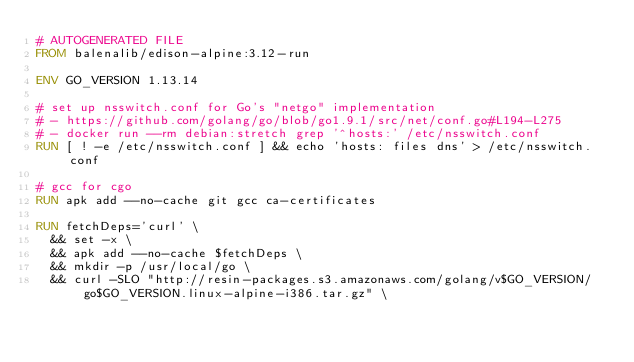Convert code to text. <code><loc_0><loc_0><loc_500><loc_500><_Dockerfile_># AUTOGENERATED FILE
FROM balenalib/edison-alpine:3.12-run

ENV GO_VERSION 1.13.14

# set up nsswitch.conf for Go's "netgo" implementation
# - https://github.com/golang/go/blob/go1.9.1/src/net/conf.go#L194-L275
# - docker run --rm debian:stretch grep '^hosts:' /etc/nsswitch.conf
RUN [ ! -e /etc/nsswitch.conf ] && echo 'hosts: files dns' > /etc/nsswitch.conf

# gcc for cgo
RUN apk add --no-cache git gcc ca-certificates

RUN fetchDeps='curl' \
	&& set -x \
	&& apk add --no-cache $fetchDeps \
	&& mkdir -p /usr/local/go \
	&& curl -SLO "http://resin-packages.s3.amazonaws.com/golang/v$GO_VERSION/go$GO_VERSION.linux-alpine-i386.tar.gz" \</code> 